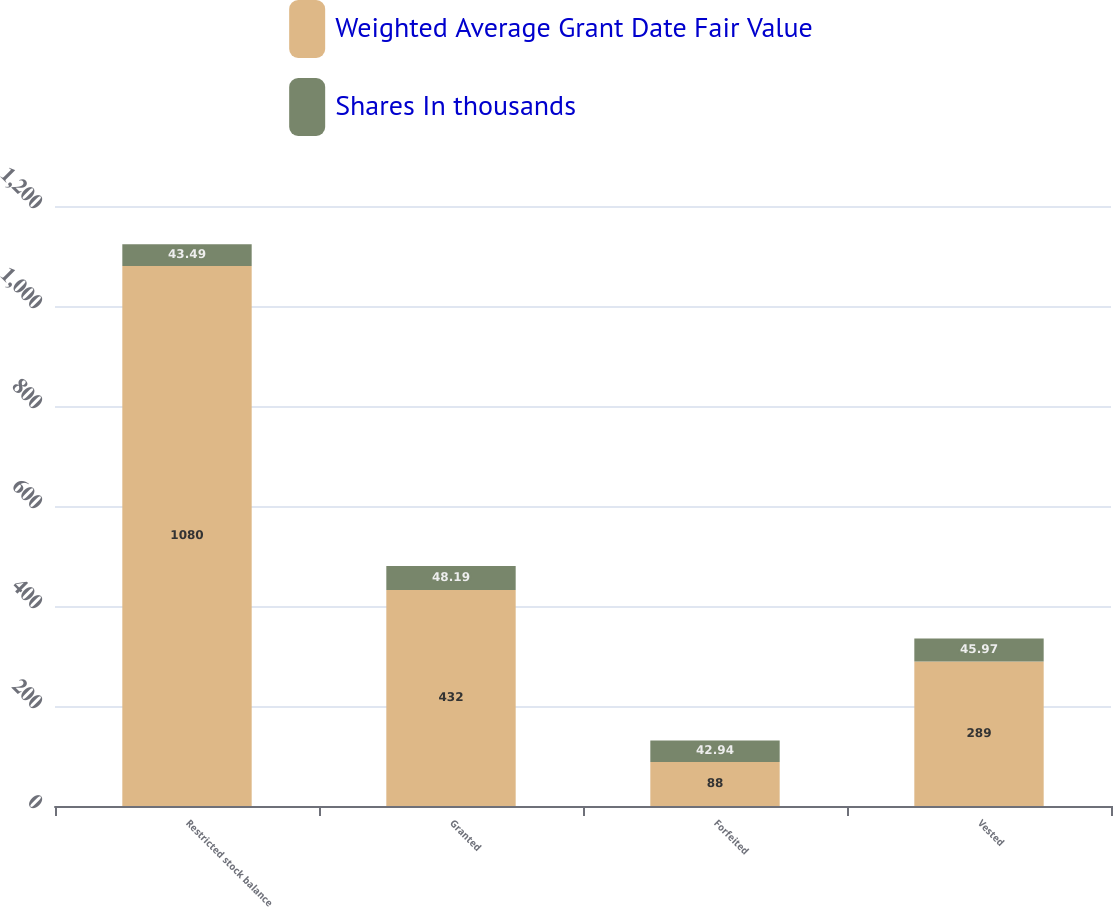Convert chart. <chart><loc_0><loc_0><loc_500><loc_500><stacked_bar_chart><ecel><fcel>Restricted stock balance<fcel>Granted<fcel>Forfeited<fcel>Vested<nl><fcel>Weighted Average Grant Date Fair Value<fcel>1080<fcel>432<fcel>88<fcel>289<nl><fcel>Shares In thousands<fcel>43.49<fcel>48.19<fcel>42.94<fcel>45.97<nl></chart> 